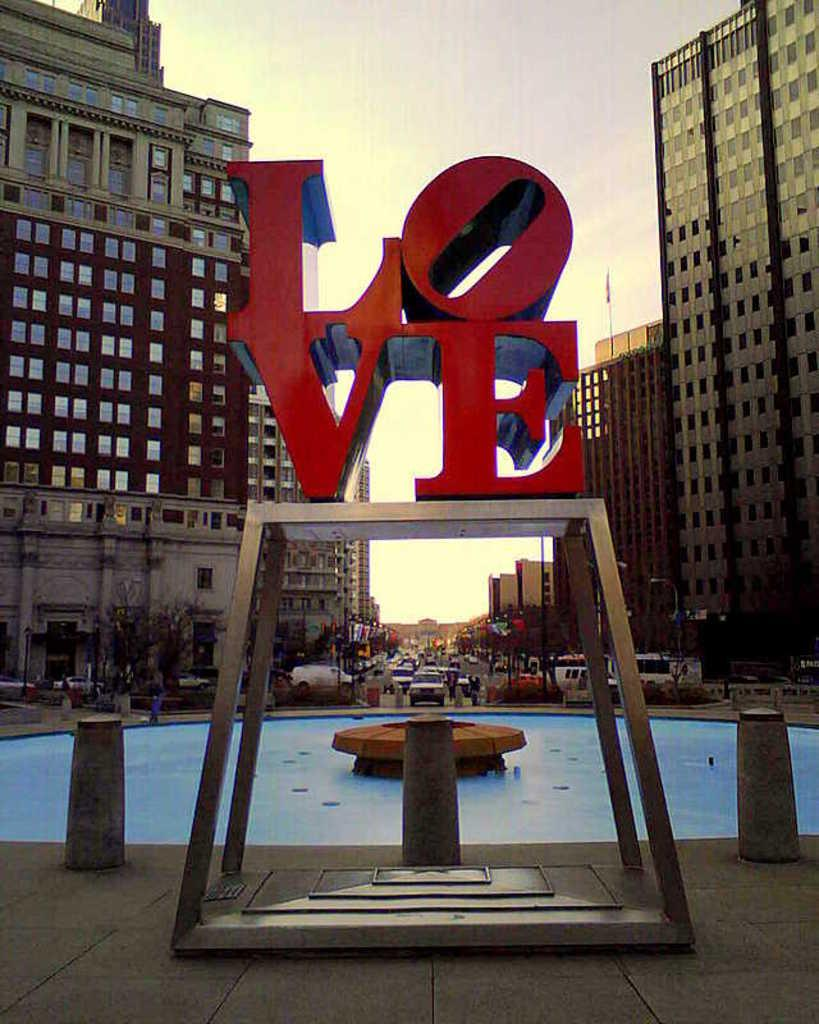What is located in the center of the image? There are letters on a stand in the center of the image. What can be seen in the background of the image? There are buildings, vehicles, plants, water, a flag, and the sky visible in the background of the image. What type of cake is being served at the event in the image? There is no cake present in the image; it features letters on a stand and various background elements. Are there any people wearing masks in the image? There is no indication of people or masks in the image. 